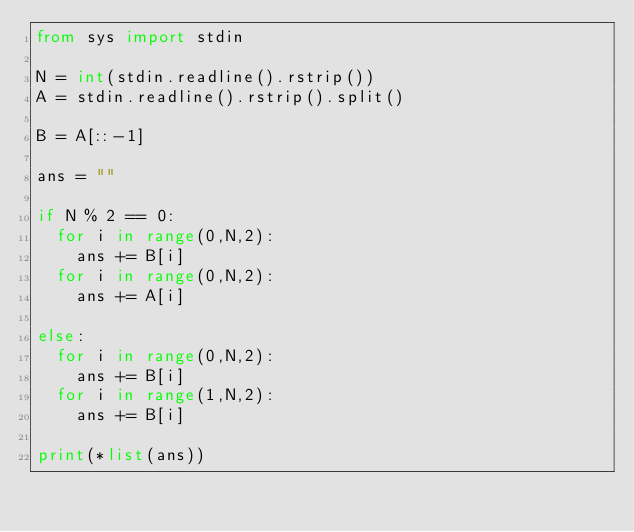Convert code to text. <code><loc_0><loc_0><loc_500><loc_500><_Python_>from sys import stdin

N = int(stdin.readline().rstrip())
A = stdin.readline().rstrip().split()

B = A[::-1]

ans = ""

if N % 2 == 0:
  for i in range(0,N,2):
    ans += B[i]
  for i in range(0,N,2):
    ans += A[i]
  
else:
  for i in range(0,N,2):
    ans += B[i]
  for i in range(1,N,2):
    ans += B[i]

print(*list(ans))</code> 